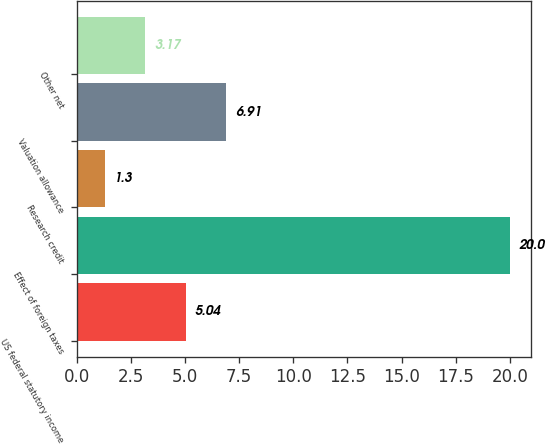Convert chart to OTSL. <chart><loc_0><loc_0><loc_500><loc_500><bar_chart><fcel>US federal statutory income<fcel>Effect of foreign taxes<fcel>Research credit<fcel>Valuation allowance<fcel>Other net<nl><fcel>5.04<fcel>20<fcel>1.3<fcel>6.91<fcel>3.17<nl></chart> 